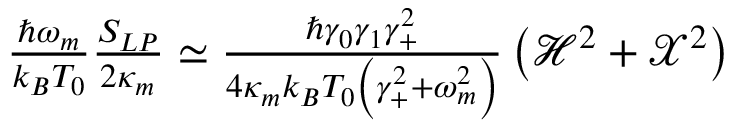Convert formula to latex. <formula><loc_0><loc_0><loc_500><loc_500>\begin{array} { r } { \frac { \hbar { \omega } _ { m } } { k _ { B } T _ { 0 } } \frac { S _ { L P } } { 2 \kappa _ { m } } \simeq \frac { \hbar { \gamma } _ { 0 } \gamma _ { 1 } \gamma _ { + } ^ { 2 } } { 4 \kappa _ { m } k _ { B } T _ { 0 } \left ( \gamma _ { + } ^ { 2 } + \omega _ { m } ^ { 2 } \right ) } \left ( \mathcal { H } ^ { 2 } + \mathcal { X } ^ { 2 } \right ) } \end{array}</formula> 